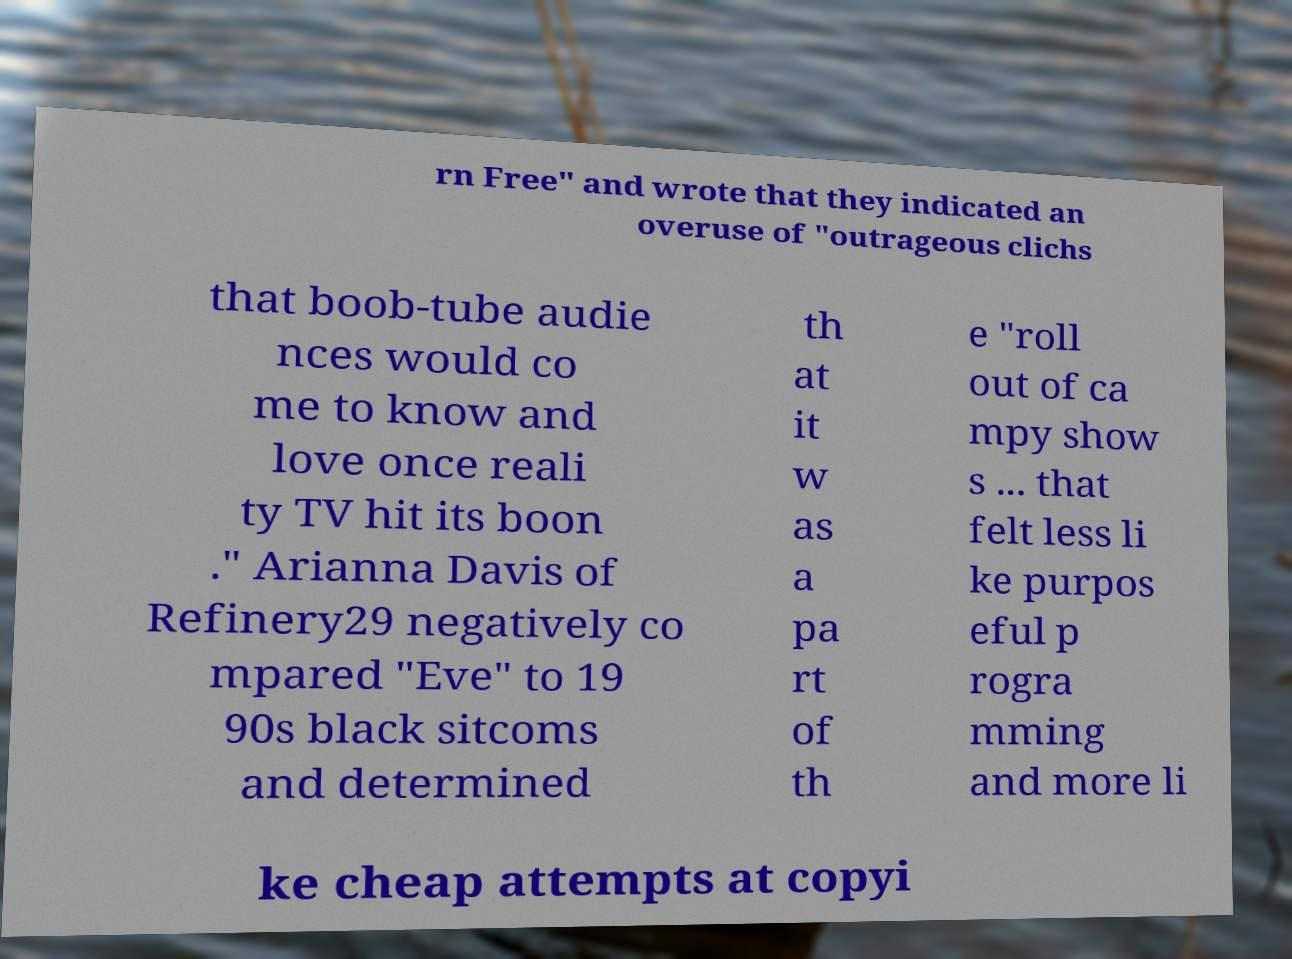I need the written content from this picture converted into text. Can you do that? rn Free" and wrote that they indicated an overuse of "outrageous clichs that boob-tube audie nces would co me to know and love once reali ty TV hit its boon ." Arianna Davis of Refinery29 negatively co mpared "Eve" to 19 90s black sitcoms and determined th at it w as a pa rt of th e "roll out of ca mpy show s ... that felt less li ke purpos eful p rogra mming and more li ke cheap attempts at copyi 